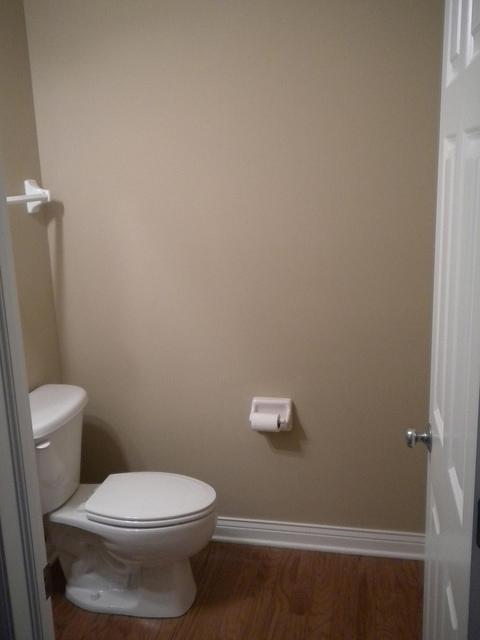Do you see any trash cans in this bathroom?
Concise answer only. No. Is this a colorful bathroom?
Concise answer only. No. Lid open,or closes?
Give a very brief answer. Closed. Is there painting tape on the walls?
Be succinct. No. What kind of flooring is on this bathroom floor?
Give a very brief answer. Wood. Is there a mirror in the picture?
Give a very brief answer. No. What color is the wall?
Write a very short answer. Beige. What is the object in the left corner?
Concise answer only. Toilet. 